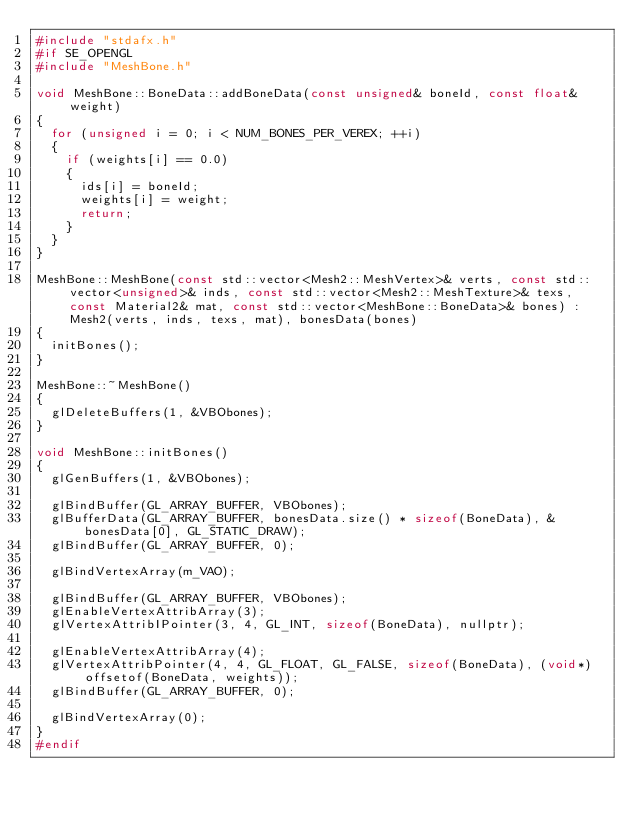Convert code to text. <code><loc_0><loc_0><loc_500><loc_500><_C++_>#include "stdafx.h"
#if SE_OPENGL
#include "MeshBone.h"

void MeshBone::BoneData::addBoneData(const unsigned& boneId, const float& weight)
{
	for (unsigned i = 0; i < NUM_BONES_PER_VEREX; ++i)
	{
		if (weights[i] == 0.0)
		{
			ids[i] = boneId;
			weights[i] = weight;
			return;
		}
	}
}

MeshBone::MeshBone(const std::vector<Mesh2::MeshVertex>& verts, const std::vector<unsigned>& inds, const std::vector<Mesh2::MeshTexture>& texs, const Material2& mat, const std::vector<MeshBone::BoneData>& bones) : Mesh2(verts, inds, texs, mat), bonesData(bones)
{
	initBones();
}

MeshBone::~MeshBone()
{
	glDeleteBuffers(1, &VBObones);
}

void MeshBone::initBones()
{
	glGenBuffers(1, &VBObones);

	glBindBuffer(GL_ARRAY_BUFFER, VBObones);
	glBufferData(GL_ARRAY_BUFFER, bonesData.size() * sizeof(BoneData), &bonesData[0], GL_STATIC_DRAW);
	glBindBuffer(GL_ARRAY_BUFFER, 0);

	glBindVertexArray(m_VAO);

	glBindBuffer(GL_ARRAY_BUFFER, VBObones);
	glEnableVertexAttribArray(3);
	glVertexAttribIPointer(3, 4, GL_INT, sizeof(BoneData), nullptr);

	glEnableVertexAttribArray(4);
	glVertexAttribPointer(4, 4, GL_FLOAT, GL_FALSE, sizeof(BoneData), (void*)offsetof(BoneData, weights));
	glBindBuffer(GL_ARRAY_BUFFER, 0);

	glBindVertexArray(0);
}
#endif</code> 